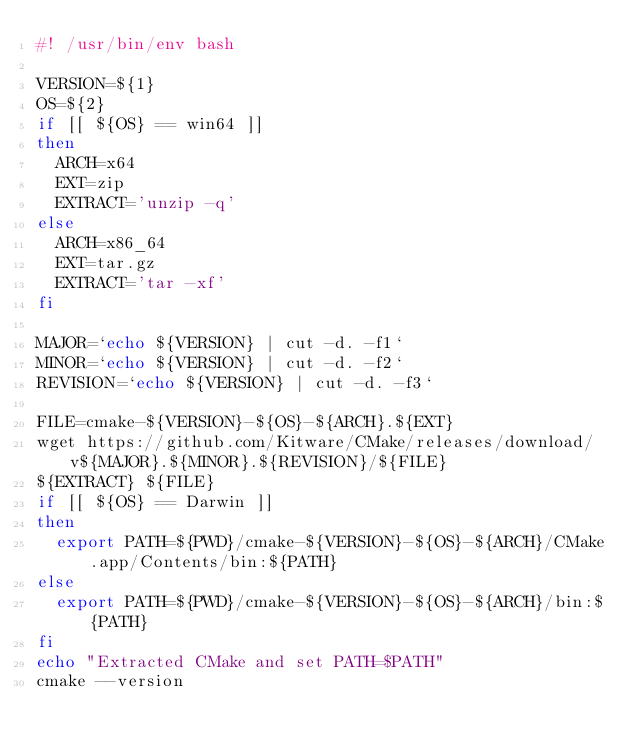Convert code to text. <code><loc_0><loc_0><loc_500><loc_500><_Bash_>#! /usr/bin/env bash

VERSION=${1}
OS=${2}
if [[ ${OS} == win64 ]]
then
  ARCH=x64
  EXT=zip
  EXTRACT='unzip -q'
else
  ARCH=x86_64
  EXT=tar.gz
  EXTRACT='tar -xf'
fi

MAJOR=`echo ${VERSION} | cut -d. -f1`
MINOR=`echo ${VERSION} | cut -d. -f2`
REVISION=`echo ${VERSION} | cut -d. -f3`

FILE=cmake-${VERSION}-${OS}-${ARCH}.${EXT}
wget https://github.com/Kitware/CMake/releases/download/v${MAJOR}.${MINOR}.${REVISION}/${FILE}
${EXTRACT} ${FILE}
if [[ ${OS} == Darwin ]]
then
  export PATH=${PWD}/cmake-${VERSION}-${OS}-${ARCH}/CMake.app/Contents/bin:${PATH}
else
  export PATH=${PWD}/cmake-${VERSION}-${OS}-${ARCH}/bin:${PATH}
fi
echo "Extracted CMake and set PATH=$PATH"
cmake --version
</code> 